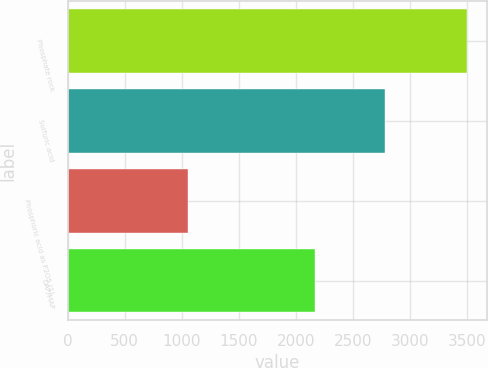<chart> <loc_0><loc_0><loc_500><loc_500><bar_chart><fcel>Phosphate rock<fcel>Sulfuric acid<fcel>Phosphoric acid as P2O5 (1)<fcel>DAP/MAP<nl><fcel>3500<fcel>2785<fcel>1055<fcel>2165<nl></chart> 